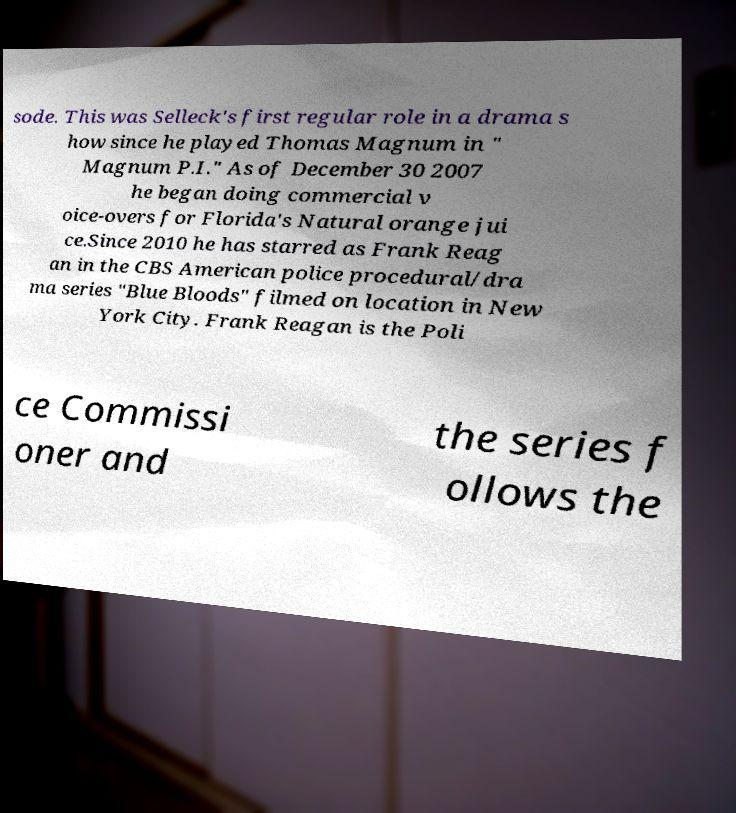Can you accurately transcribe the text from the provided image for me? sode. This was Selleck's first regular role in a drama s how since he played Thomas Magnum in " Magnum P.I." As of December 30 2007 he began doing commercial v oice-overs for Florida's Natural orange jui ce.Since 2010 he has starred as Frank Reag an in the CBS American police procedural/dra ma series "Blue Bloods" filmed on location in New York City. Frank Reagan is the Poli ce Commissi oner and the series f ollows the 